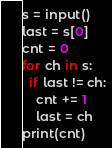Convert code to text. <code><loc_0><loc_0><loc_500><loc_500><_Python_>s = input()
last = s[0]
cnt = 0
for ch in s:
  if last != ch:
    cnt += 1
    last = ch
print(cnt)</code> 